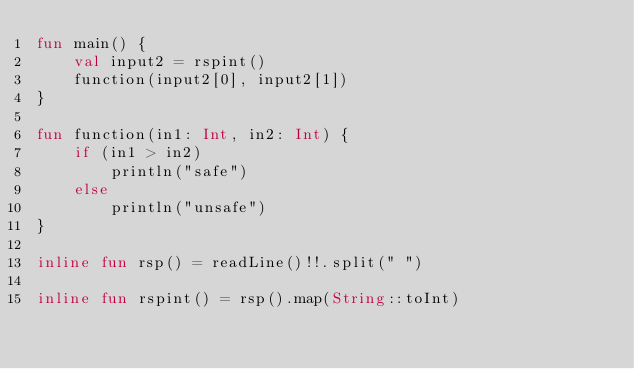Convert code to text. <code><loc_0><loc_0><loc_500><loc_500><_Kotlin_>fun main() {
    val input2 = rspint()
    function(input2[0], input2[1])
}

fun function(in1: Int, in2: Int) {
    if (in1 > in2)
        println("safe")
    else
        println("unsafe")
}

inline fun rsp() = readLine()!!.split(" ")

inline fun rspint() = rsp().map(String::toInt)</code> 